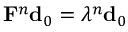Convert formula to latex. <formula><loc_0><loc_0><loc_500><loc_500>{ F } ^ { n } { d } _ { 0 } = \lambda ^ { n } { d } _ { 0 }</formula> 